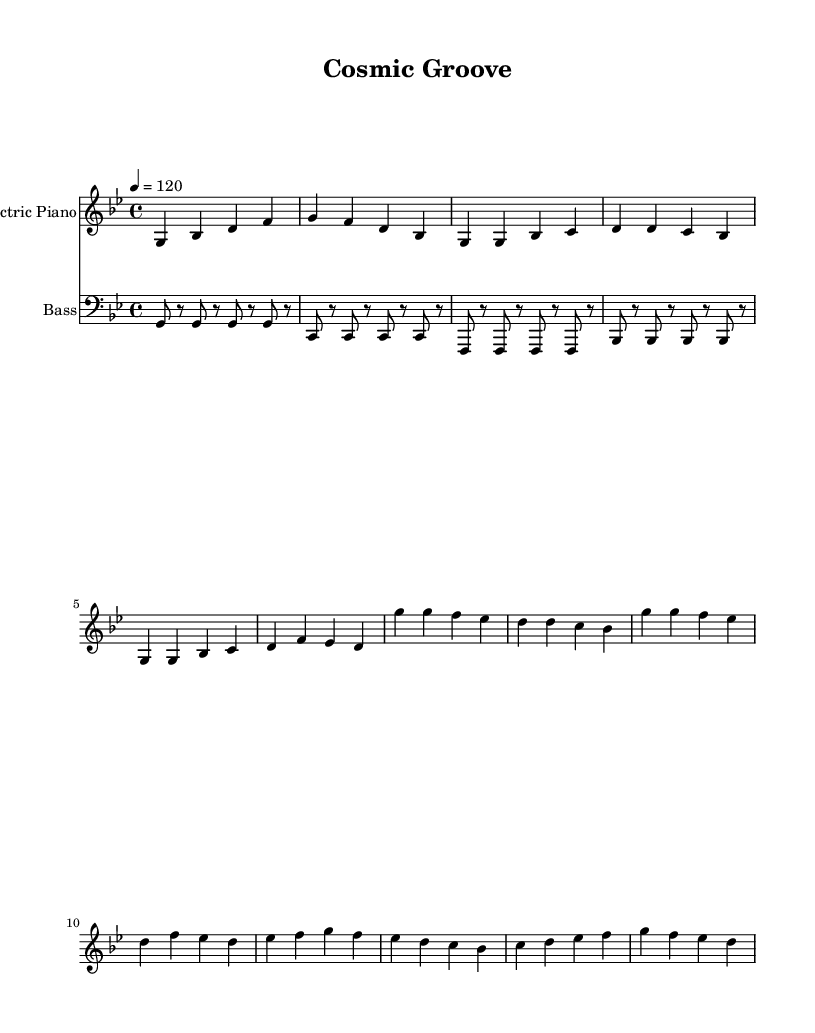What is the key signature of this music? The key signature of the piece is G minor, which features two flats (B flat and E flat). This is indicated at the beginning of the staff in the key signature section.
Answer: G minor What is the time signature of the music? The time signature is 4/4, which means there are 4 beats per measure and the quarter note gets one beat. This can be identified in the initial part of the notation, showing the fraction format.
Answer: 4/4 What is the tempo marking of the piece? The tempo marking is 120 BPM (beats per minute), which suggests a moderately fast pace. This is indicated at the beginning of the score with the tempo notation "4 = 120".
Answer: 120 How many measures are there in the chorus section? The chorus section consists of four measures, as counted from the respective grouping of notes and bars labeled "Chorus" in the sheet music.
Answer: 4 Which instrument plays the bass line? The bass line is played by the bass guitar, which is specified in the staff label and the clef used (bass clef) corresponding to lower pitch notation.
Answer: Bass What is the first chord played in the intro? The first chord played in the intro is G minor, as indicated by the sequence of notes starting with G, which is the root of the G minor chord, along with B flat and D.
Answer: G minor What type of rhythmic pattern is used in the bass guitar part? The bass guitar part uses a simplified syncopated pattern, which accentuates different beats and creates a groove. This is evident by the alternating rests and notes in a rhythmic sequence.
Answer: Syncopated pattern 